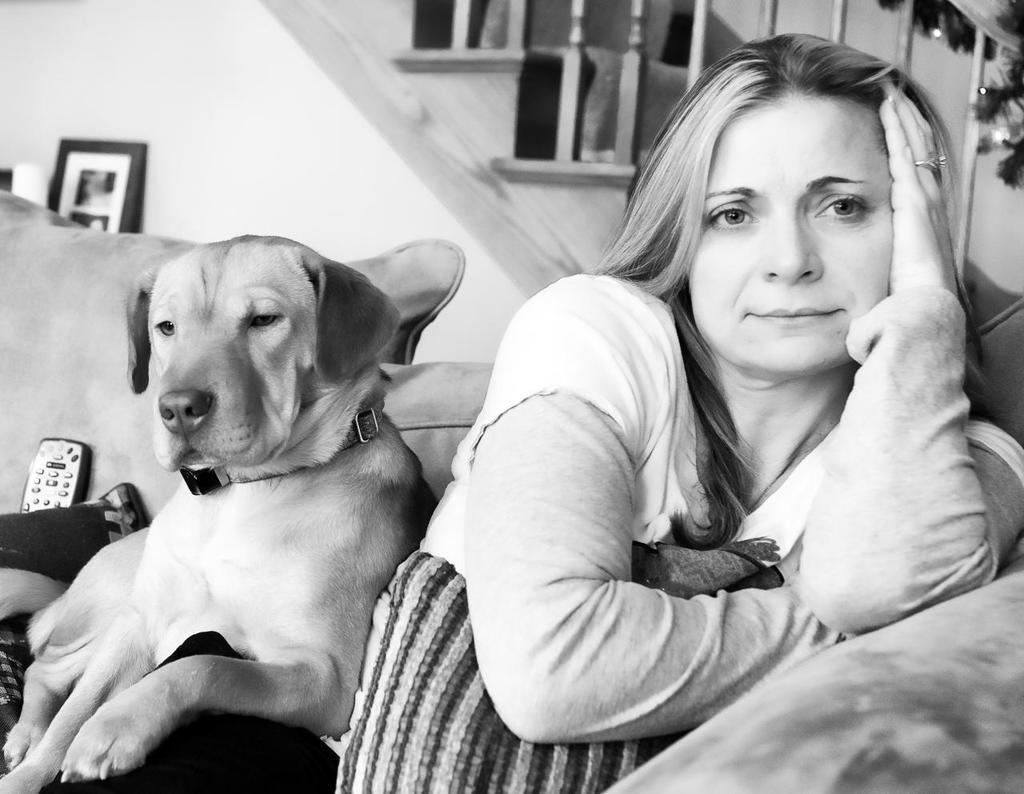Who is present in the image? There is a lady and a dog in the image. What are they doing in the image? Both the lady and the dog are sitting on a sofa. What can be seen in the background of the image? There are stairs and a photo frame visible in the background. What type of ice is being offered to the men in the image? There are no men or ice present in the image. 